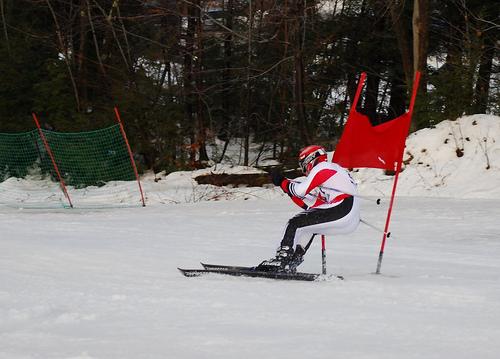What color flag is this?
Concise answer only. Red. What is the main color of the helmet?
Quick response, please. Red. What is this person doing?
Be succinct. Skiing. 